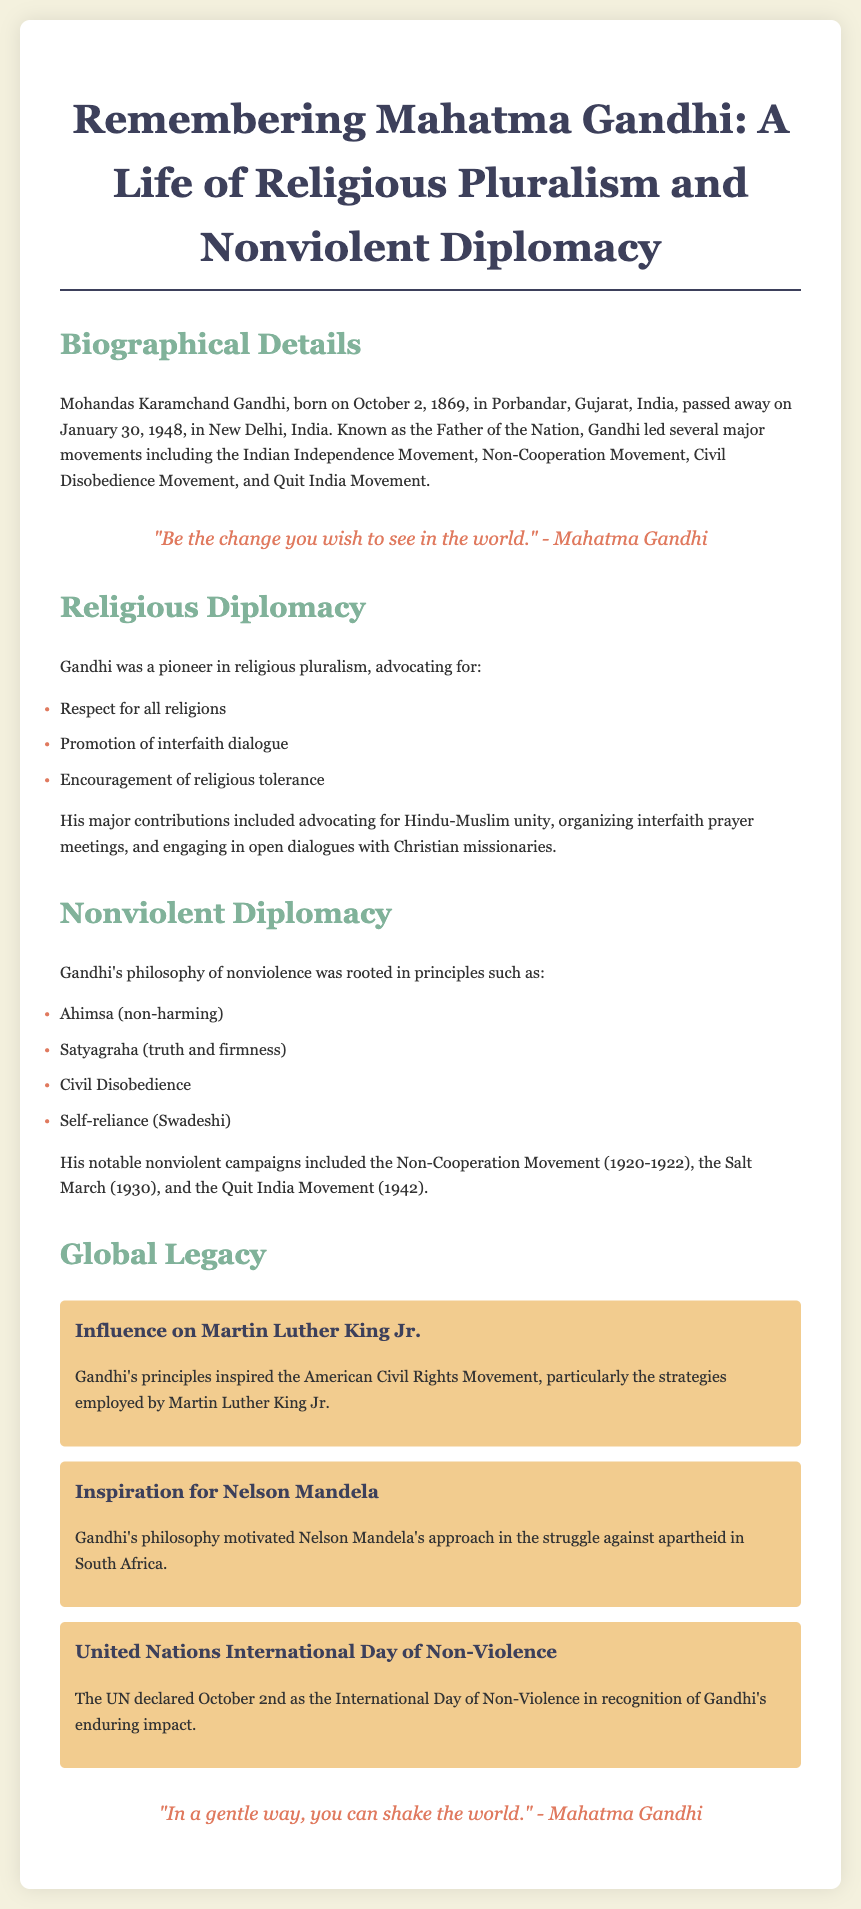What is Mahatma Gandhi known as? The document refers to Gandhi as the "Father of the Nation."
Answer: Father of the Nation When was Gandhi born? The document states that Gandhi was born on October 2, 1869.
Answer: October 2, 1869 What philosophy did Gandhi's nonviolent diplomacy rest upon? The document indicates that Gandhi's nonviolent diplomacy is rooted in the principle of Ahimsa.
Answer: Ahimsa What movement did Gandhi lead in 1930? The document mentions the Salt March as a notable campaign Gandhi led in 1930.
Answer: Salt March Who was influenced by Gandhi's principles in the American Civil Rights Movement? According to the document, Martin Luther King Jr. was influenced by Gandhi's principles.
Answer: Martin Luther King Jr What international day is celebrated in recognition of Gandhi's impact? The document notes that October 2nd is recognized as the International Day of Non-Violence.
Answer: International Day of Non-Violence What was Gandhi's approach to religious diplomacy? The document describes Gandhi's approach as advocating for respect for all religions.
Answer: Respect for all religions What major interfaith initiative did Gandhi organize? The document states that Gandhi organized interfaith prayer meetings.
Answer: Interfaith prayer meetings 